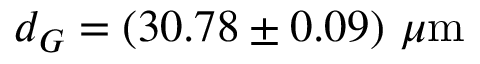Convert formula to latex. <formula><loc_0><loc_0><loc_500><loc_500>d _ { G } = ( 3 0 . 7 8 \pm 0 . 0 9 ) \mu m</formula> 